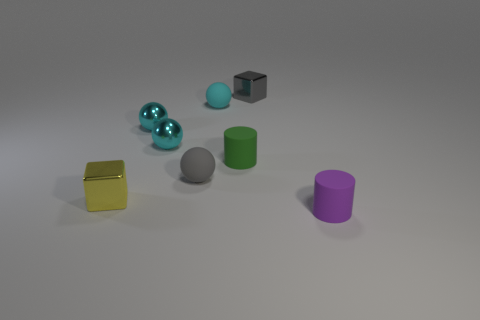Subtract all gray cubes. How many cyan spheres are left? 3 Subtract 1 balls. How many balls are left? 3 Subtract all cyan spheres. Subtract all green cylinders. How many spheres are left? 1 Add 1 cyan matte things. How many objects exist? 9 Subtract all cubes. How many objects are left? 6 Subtract 1 purple cylinders. How many objects are left? 7 Subtract all gray cubes. Subtract all tiny cyan spheres. How many objects are left? 4 Add 6 small yellow blocks. How many small yellow blocks are left? 7 Add 1 cyan metal spheres. How many cyan metal spheres exist? 3 